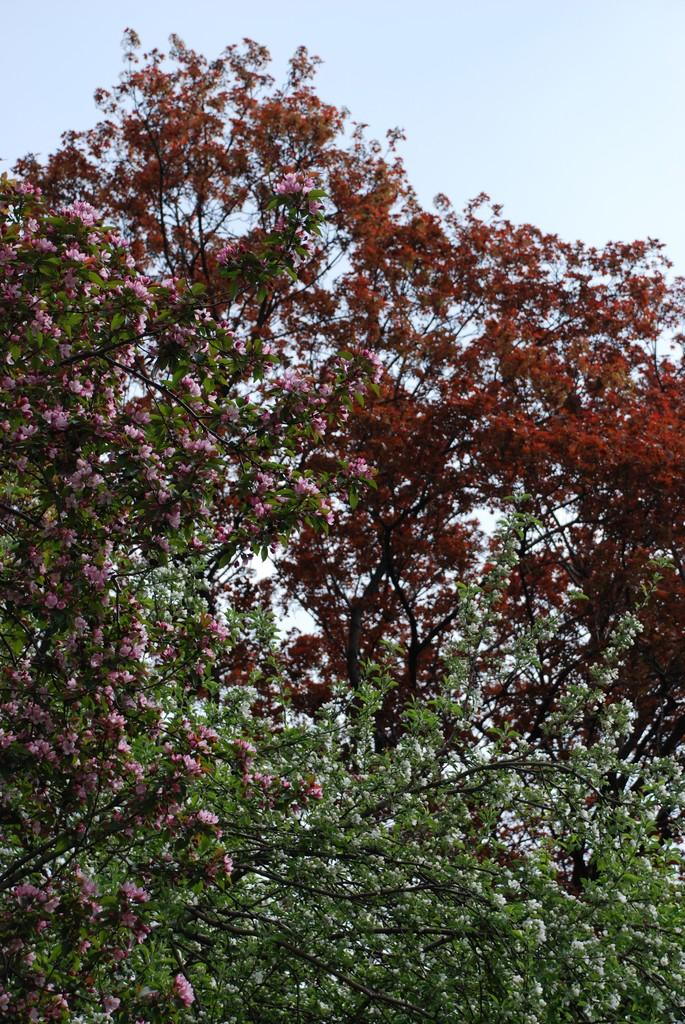What is located in the foreground of the image? There are flowers in the foreground of the image. What can be seen near the flowers? The flowers are near trees. What is visible at the top of the image? The sky is visible at the top of the image. What is the name of the industry that is depicted in the image? There is no industry depicted in the image; it features flowers and trees. What day of the week is shown in the image? The image does not depict a specific day of the week; it is a still image of flowers, trees, and the sky. 